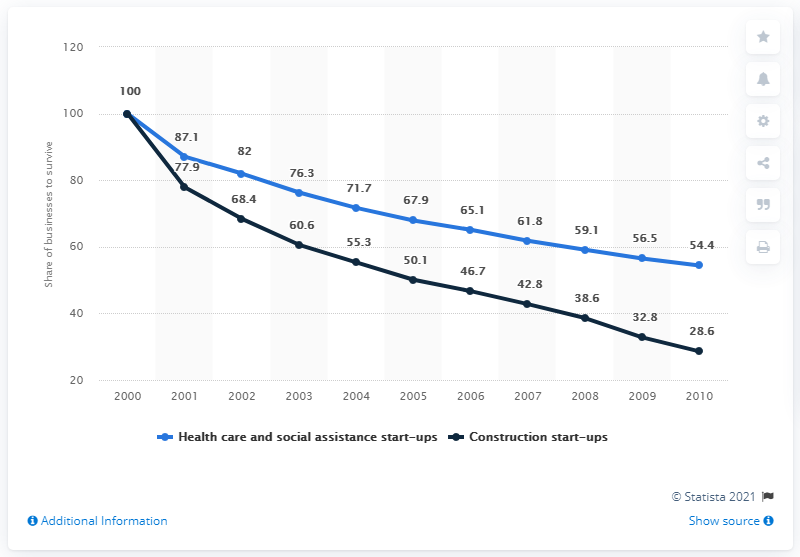What does the data from 2005 indicate for both sectors shown in the graph? In 2005, the data indicates that the share of healthcare and social assistance start-ups experienced a decrease to approximately 71.7, while construction start-ups declined to about 55.3, as a percentage of total businesses in the United States. 